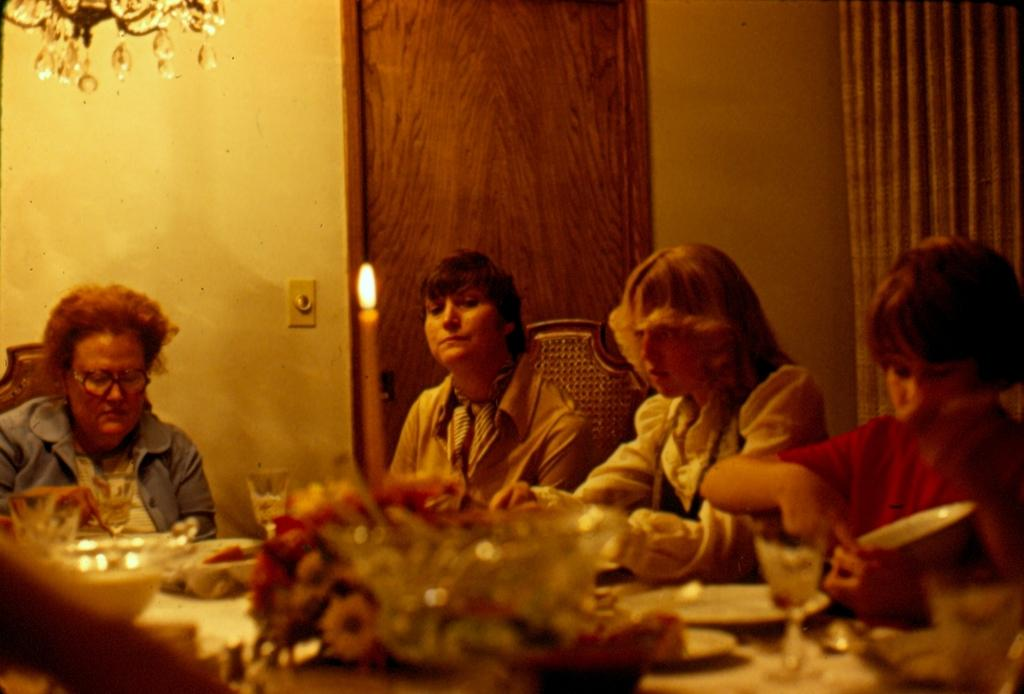What are the people in the image doing? The people in the image are sitting on chairs. What object can be seen that provides light? There is a candle in the image. What items are present that can be used for drinking? There are glasses in the image. How many baskets are visible in the image? There are no baskets present in the image. What type of number is written on the leg of the chair? There is no number written on the leg of the chair in the image. 